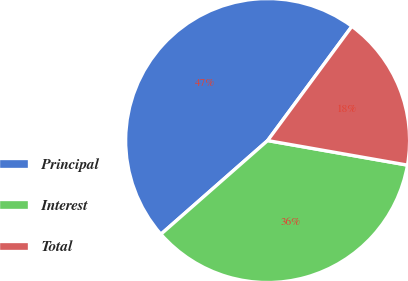Convert chart to OTSL. <chart><loc_0><loc_0><loc_500><loc_500><pie_chart><fcel>Principal<fcel>Interest<fcel>Total<nl><fcel>46.58%<fcel>35.77%<fcel>17.65%<nl></chart> 